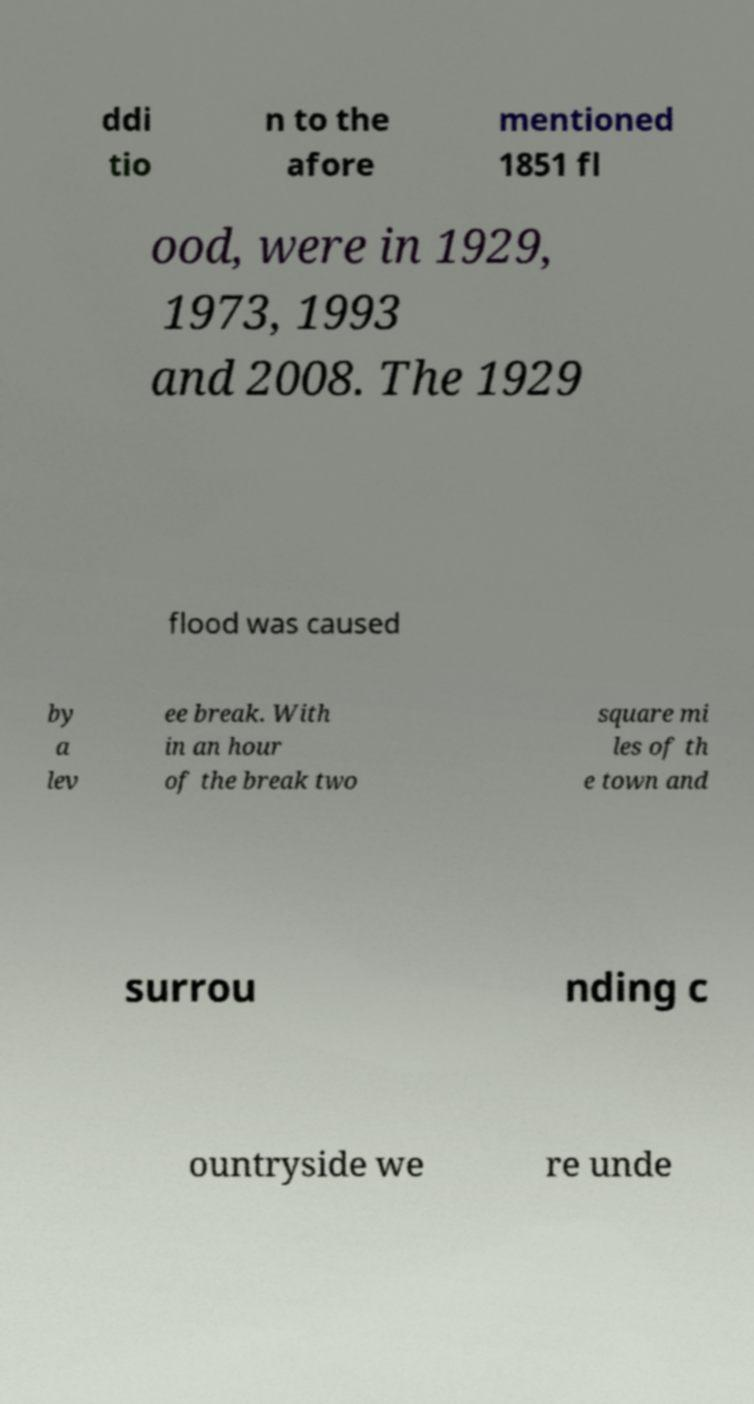Please read and relay the text visible in this image. What does it say? ddi tio n to the afore mentioned 1851 fl ood, were in 1929, 1973, 1993 and 2008. The 1929 flood was caused by a lev ee break. With in an hour of the break two square mi les of th e town and surrou nding c ountryside we re unde 